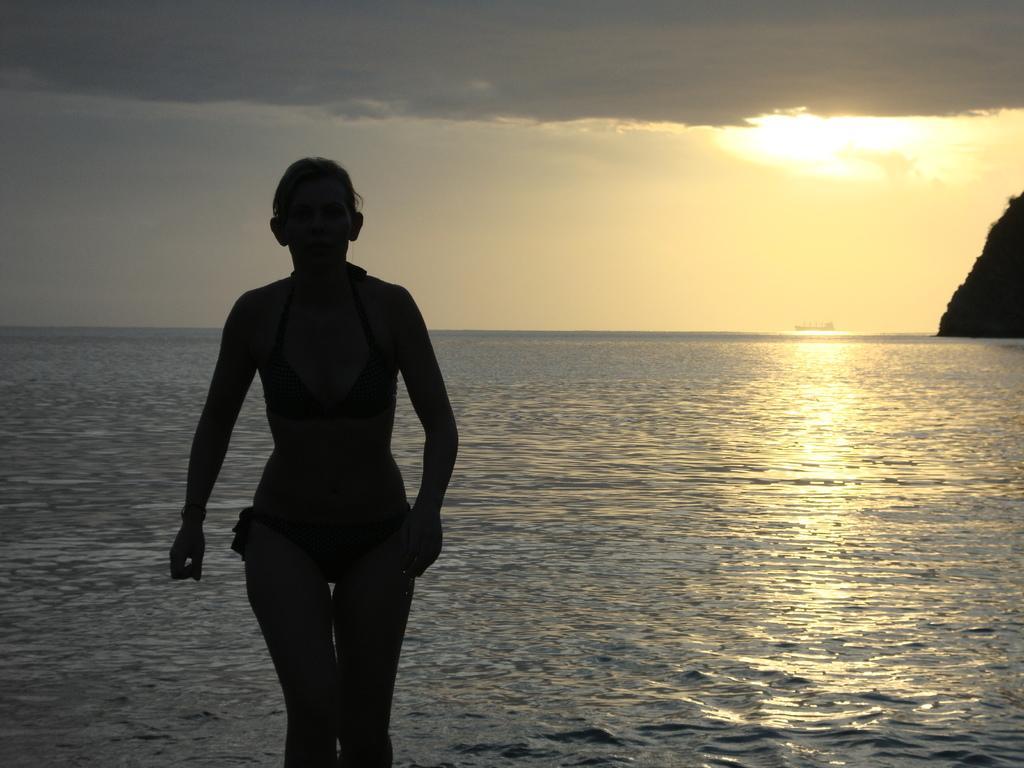Please provide a concise description of this image. In this picture we can see a person is standing on the path and behind the person there is water and a sky. 